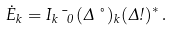Convert formula to latex. <formula><loc_0><loc_0><loc_500><loc_500>\dot { E } _ { k } = I _ { k } \, \mu _ { 0 } \, ( \Delta \nu ) _ { k } ( \Delta \omega ) ^ { * } \, .</formula> 